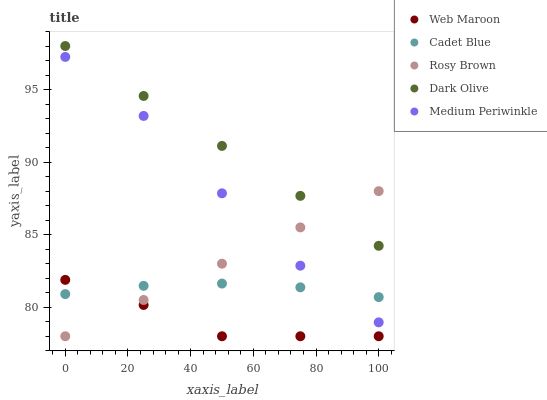Does Web Maroon have the minimum area under the curve?
Answer yes or no. Yes. Does Dark Olive have the maximum area under the curve?
Answer yes or no. Yes. Does Medium Periwinkle have the minimum area under the curve?
Answer yes or no. No. Does Medium Periwinkle have the maximum area under the curve?
Answer yes or no. No. Is Dark Olive the smoothest?
Answer yes or no. Yes. Is Medium Periwinkle the roughest?
Answer yes or no. Yes. Is Rosy Brown the smoothest?
Answer yes or no. No. Is Rosy Brown the roughest?
Answer yes or no. No. Does Rosy Brown have the lowest value?
Answer yes or no. Yes. Does Medium Periwinkle have the lowest value?
Answer yes or no. No. Does Dark Olive have the highest value?
Answer yes or no. Yes. Does Medium Periwinkle have the highest value?
Answer yes or no. No. Is Web Maroon less than Dark Olive?
Answer yes or no. Yes. Is Dark Olive greater than Medium Periwinkle?
Answer yes or no. Yes. Does Dark Olive intersect Rosy Brown?
Answer yes or no. Yes. Is Dark Olive less than Rosy Brown?
Answer yes or no. No. Is Dark Olive greater than Rosy Brown?
Answer yes or no. No. Does Web Maroon intersect Dark Olive?
Answer yes or no. No. 